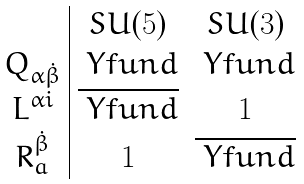Convert formula to latex. <formula><loc_0><loc_0><loc_500><loc_500>\begin{array} { c | c c } & S U ( 5 ) & S U ( 3 ) \\ Q _ { \alpha \dot { \beta } } & \ Y f u n d & \ Y f u n d \\ L ^ { \alpha i } & \overline { \ Y f u n d } & { 1 } \\ R ^ { \dot { \beta } } _ { a } & { 1 } & \overline { \ Y f u n d } \end{array}</formula> 